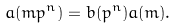<formula> <loc_0><loc_0><loc_500><loc_500>a ( m p ^ { n } ) = b ( p ^ { n } ) a ( m ) .</formula> 